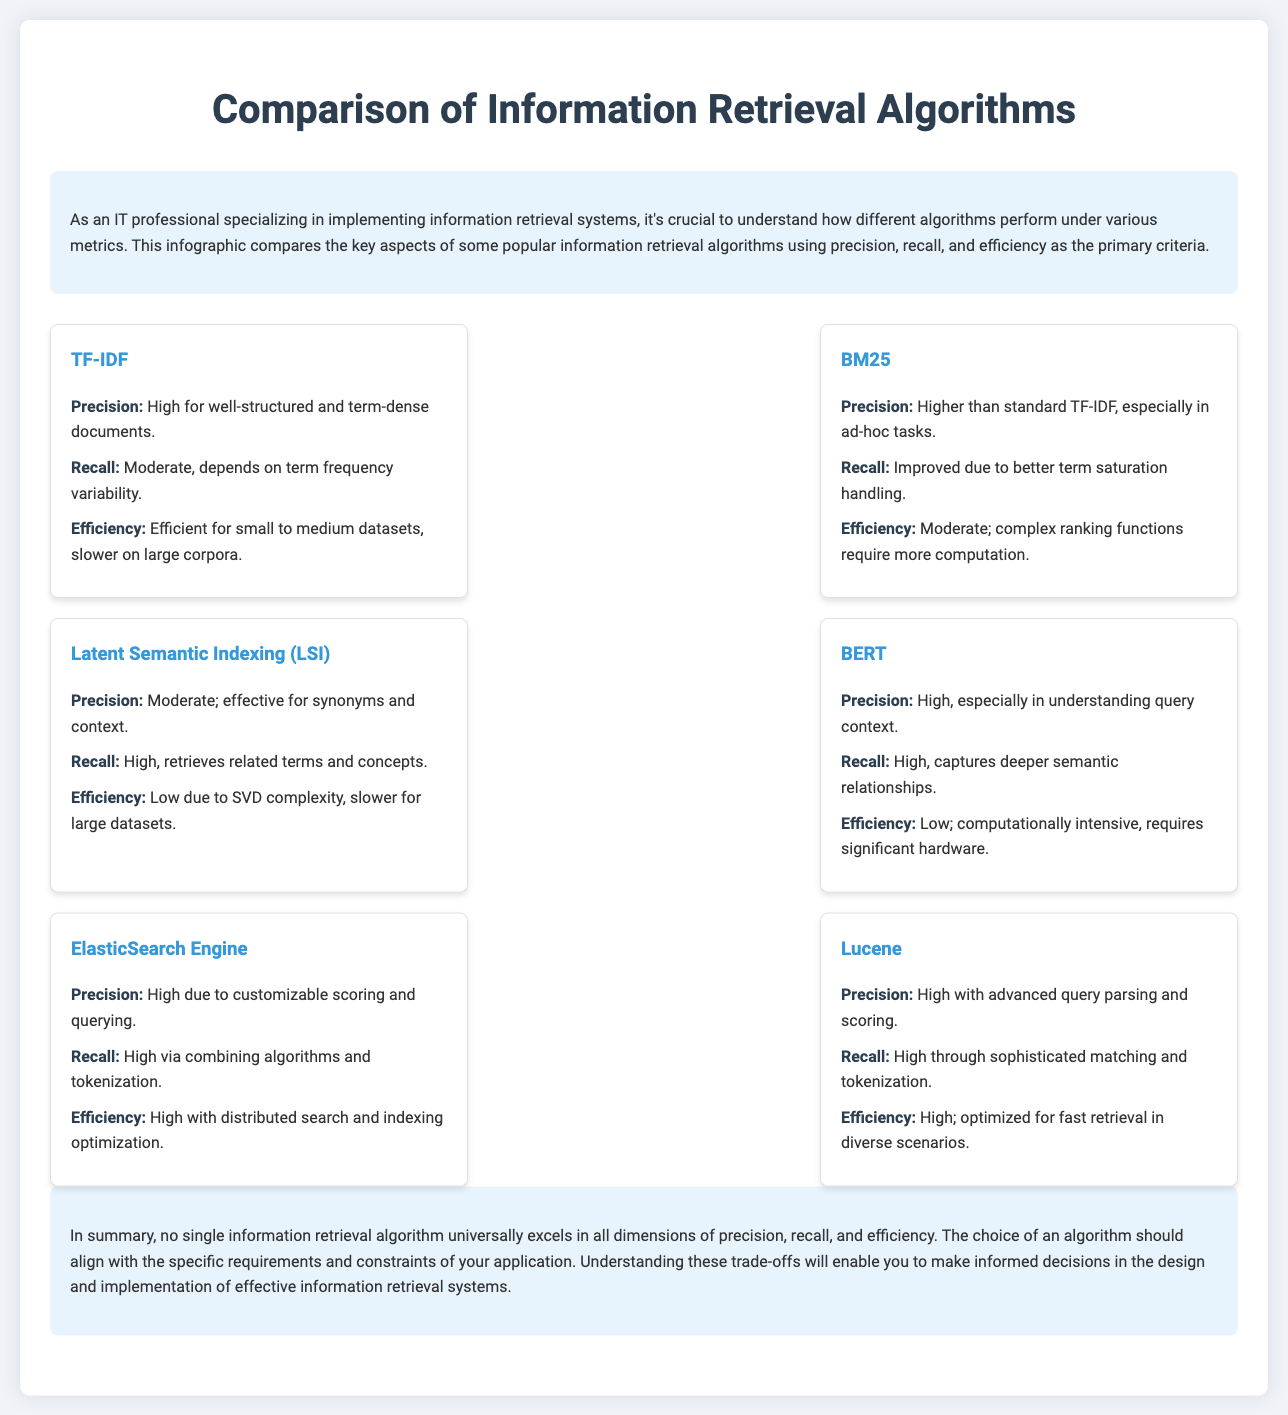What is the precision of TF-IDF? The precision for TF-IDF is described as "High for well-structured and term-dense documents."
Answer: High for well-structured and term-dense documents What algorithm has higher precision than standard TF-IDF? The algorithm mentioned to have higher precision than standard TF-IDF is BM25.
Answer: BM25 Which algorithm is known for low efficiency due to SVD complexity? Latent Semantic Indexing (LSI) is noted for its low efficiency due to SVD complexity.
Answer: Latent Semantic Indexing (LSI) What is the recall rate for BERT? The recall for BERT is described as "High, captures deeper semantic relationships."
Answer: High, captures deeper semantic relationships Which retrieval algorithm is noted for high efficiency with distributed search? The algorithm noted for high efficiency with distributed search and indexing optimization is ElasticSearch Engine.
Answer: ElasticSearch Engine What is a common characteristic of Lucene's precision? Lucene's precision is characterized as "High with advanced query parsing and scoring."
Answer: High with advanced query parsing and scoring Which algorithm has a moderate recall due to term frequency variability? The algorithm with a moderate recall due to term frequency variability is TF-IDF.
Answer: TF-IDF Is BERT's efficiency considered high or low? The efficiency of BERT is classified as low because it is computationally intensive.
Answer: Low What is the main conclusion regarding information retrieval algorithms? The conclusion states that no single algorithm universally excels in all dimensions of precision, recall, and efficiency.
Answer: No single algorithm universally excels 